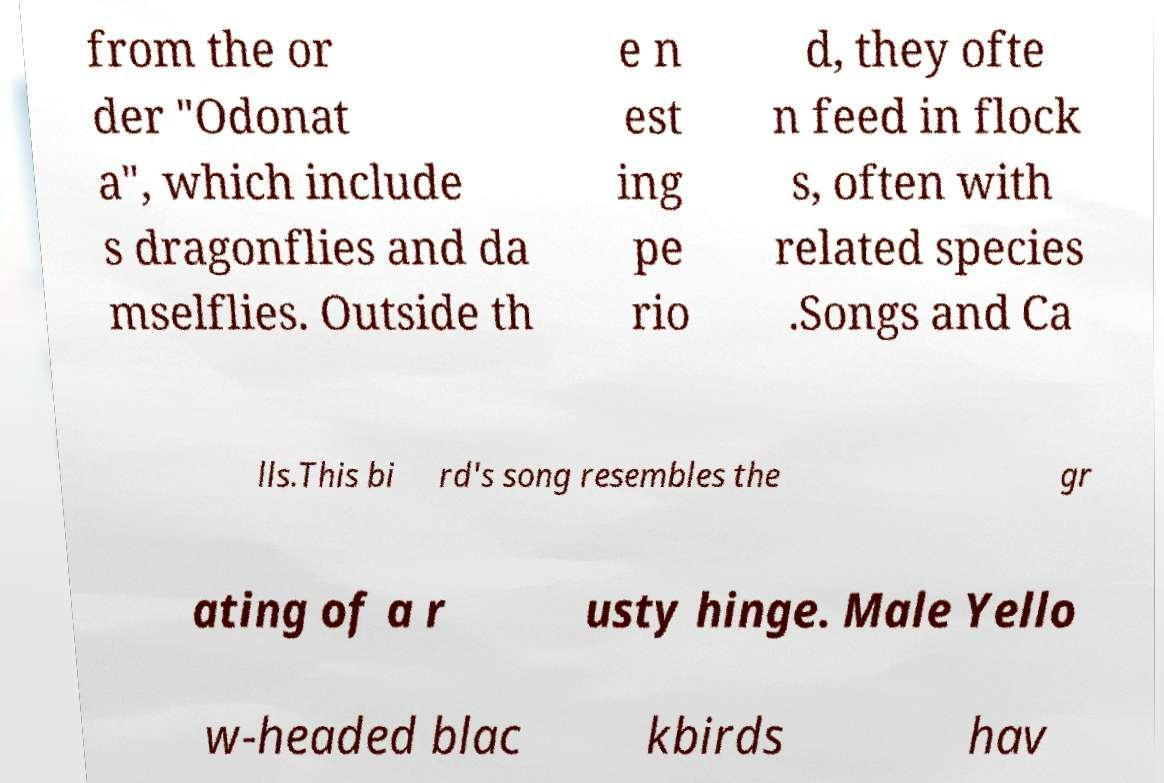Can you read and provide the text displayed in the image?This photo seems to have some interesting text. Can you extract and type it out for me? from the or der "Odonat a", which include s dragonflies and da mselflies. Outside th e n est ing pe rio d, they ofte n feed in flock s, often with related species .Songs and Ca lls.This bi rd's song resembles the gr ating of a r usty hinge. Male Yello w-headed blac kbirds hav 